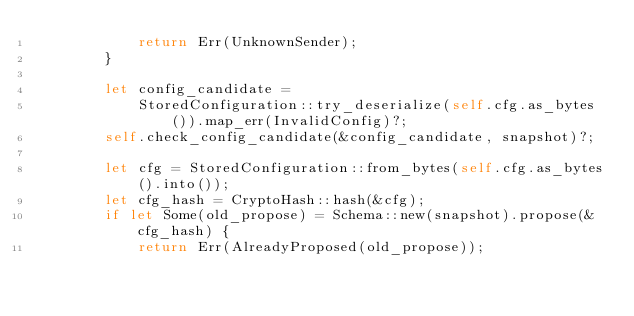Convert code to text. <code><loc_0><loc_0><loc_500><loc_500><_Rust_>            return Err(UnknownSender);
        }

        let config_candidate =
            StoredConfiguration::try_deserialize(self.cfg.as_bytes()).map_err(InvalidConfig)?;
        self.check_config_candidate(&config_candidate, snapshot)?;

        let cfg = StoredConfiguration::from_bytes(self.cfg.as_bytes().into());
        let cfg_hash = CryptoHash::hash(&cfg);
        if let Some(old_propose) = Schema::new(snapshot).propose(&cfg_hash) {
            return Err(AlreadyProposed(old_propose));</code> 